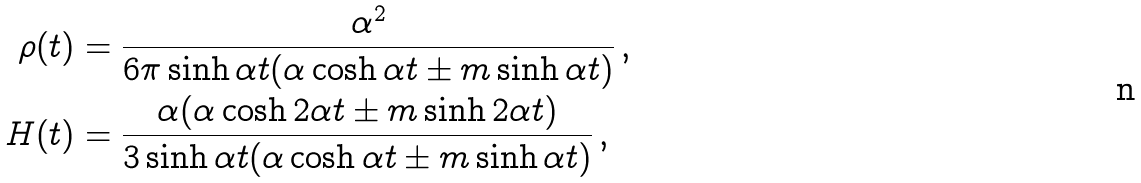Convert formula to latex. <formula><loc_0><loc_0><loc_500><loc_500>\rho ( t ) & = \frac { \alpha ^ { 2 } } { 6 \pi \sinh \alpha t ( \alpha \cosh \alpha t \pm m \sinh \alpha t ) } \, , \\ H ( t ) & = \frac { \alpha ( \alpha \cosh 2 \alpha t \pm m \sinh 2 \alpha t ) } { 3 \sinh \alpha t ( \alpha \cosh \alpha t \pm m \sinh \alpha t ) } \, ,</formula> 